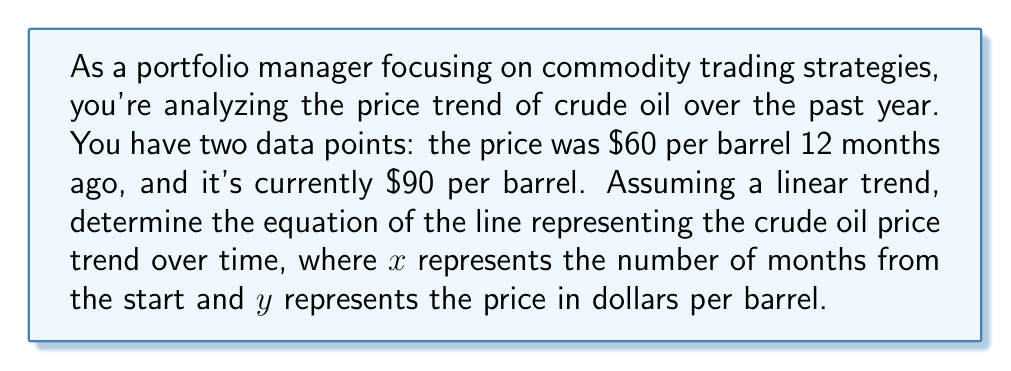What is the answer to this math problem? To determine the equation of the line, we'll use the point-slope form: $y - y_1 = m(x - x_1)$, where $m$ is the slope and $(x_1, y_1)$ is a known point on the line.

1. Identify the two points:
   $(x_1, y_1) = (0, 60)$ (12 months ago)
   $(x_2, y_2) = (12, 90)$ (current price)

2. Calculate the slope $m$:
   $$m = \frac{y_2 - y_1}{x_2 - x_1} = \frac{90 - 60}{12 - 0} = \frac{30}{12} = 2.5$$

3. Use the point-slope form with $(x_1, y_1) = (0, 60)$:
   $$y - 60 = 2.5(x - 0)$$

4. Simplify:
   $$y - 60 = 2.5x$$
   $$y = 2.5x + 60$$

This equation represents the linear trend of crude oil prices over time, where $x$ is the number of months from the start and $y$ is the price in dollars per barrel.
Answer: $y = 2.5x + 60$ 